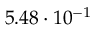<formula> <loc_0><loc_0><loc_500><loc_500>5 . 4 8 \cdot 1 0 ^ { - 1 }</formula> 